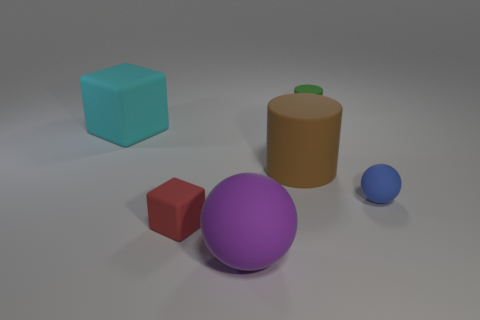Do the blue rubber ball that is behind the red matte cube and the cylinder that is on the right side of the big rubber cylinder have the same size?
Provide a succinct answer. Yes. The tiny rubber object to the left of the matte sphere on the left side of the small blue thing is what shape?
Keep it short and to the point. Cube. What number of balls have the same size as the green thing?
Ensure brevity in your answer.  1. Are there any brown metallic cylinders?
Your answer should be very brief. No. Is there anything else that has the same color as the large cube?
Make the answer very short. No. There is a large brown object that is the same material as the small red block; what shape is it?
Give a very brief answer. Cylinder. The large rubber thing in front of the tiny thing that is to the left of the rubber ball in front of the blue rubber sphere is what color?
Make the answer very short. Purple. Are there an equal number of tiny green matte things in front of the large cyan object and red metal cylinders?
Your response must be concise. Yes. There is a matte ball that is behind the rubber sphere on the left side of the large brown matte thing; is there a purple object that is to the left of it?
Your response must be concise. Yes. Are there fewer rubber spheres in front of the cyan thing than large things?
Offer a terse response. Yes. 